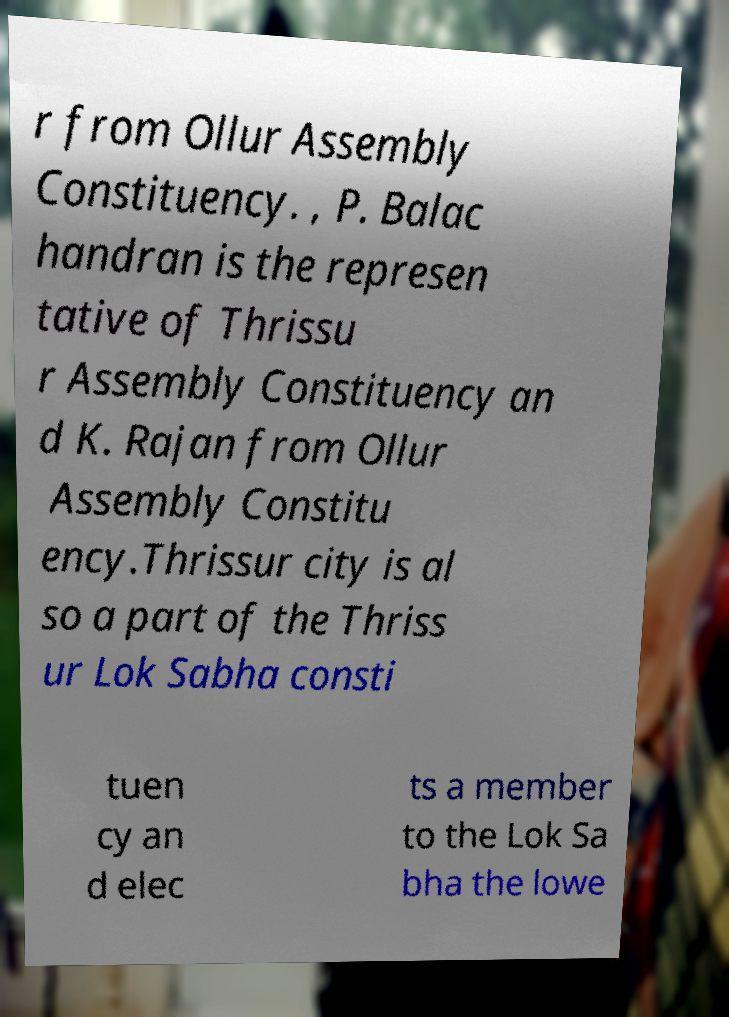Please read and relay the text visible in this image. What does it say? r from Ollur Assembly Constituency. , P. Balac handran is the represen tative of Thrissu r Assembly Constituency an d K. Rajan from Ollur Assembly Constitu ency.Thrissur city is al so a part of the Thriss ur Lok Sabha consti tuen cy an d elec ts a member to the Lok Sa bha the lowe 